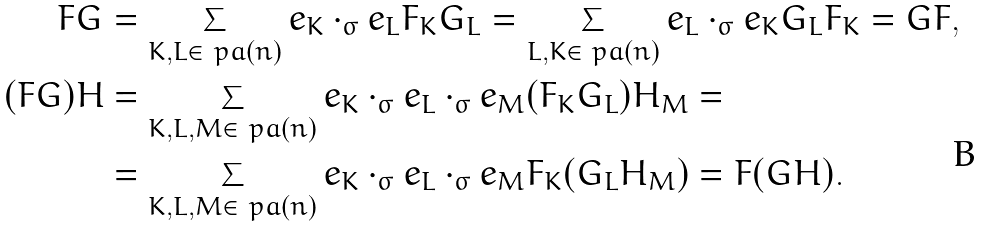Convert formula to latex. <formula><loc_0><loc_0><loc_500><loc_500>F G & = \sum _ { K , L \in \ p a ( n ) } e _ { K } \cdot _ { \sigma } e _ { L } F _ { K } G _ { L } = \sum _ { L , K \in \ p a ( n ) } e _ { L } \cdot _ { \sigma } e _ { K } G _ { L } F _ { K } = G F , \\ ( F G ) H & = \sum _ { K , L , M \in \ p a ( n ) } e _ { K } \cdot _ { \sigma } e _ { L } \cdot _ { \sigma } e _ { M } ( F _ { K } G _ { L } ) H _ { M } = \\ & = \sum _ { K , L , M \in \ p a ( n ) } e _ { K } \cdot _ { \sigma } e _ { L } \cdot _ { \sigma } e _ { M } F _ { K } ( G _ { L } H _ { M } ) = F ( G H ) .</formula> 